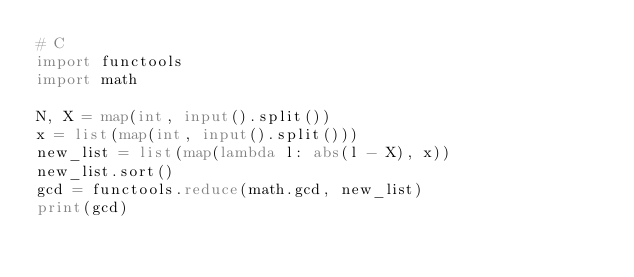Convert code to text. <code><loc_0><loc_0><loc_500><loc_500><_Python_># C
import functools
import math

N, X = map(int, input().split())
x = list(map(int, input().split()))
new_list = list(map(lambda l: abs(l - X), x))
new_list.sort()
gcd = functools.reduce(math.gcd, new_list)
print(gcd)</code> 